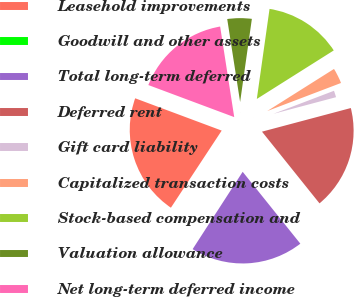<chart> <loc_0><loc_0><loc_500><loc_500><pie_chart><fcel>Leasehold improvements<fcel>Goodwill and other assets<fcel>Total long-term deferred<fcel>Deferred rent<fcel>Gift card liability<fcel>Capitalized transaction costs<fcel>Stock-based compensation and<fcel>Valuation allowance<fcel>Net long-term deferred income<nl><fcel>21.42%<fcel>0.13%<fcel>19.9%<fcel>18.38%<fcel>1.65%<fcel>3.17%<fcel>13.81%<fcel>4.69%<fcel>16.86%<nl></chart> 